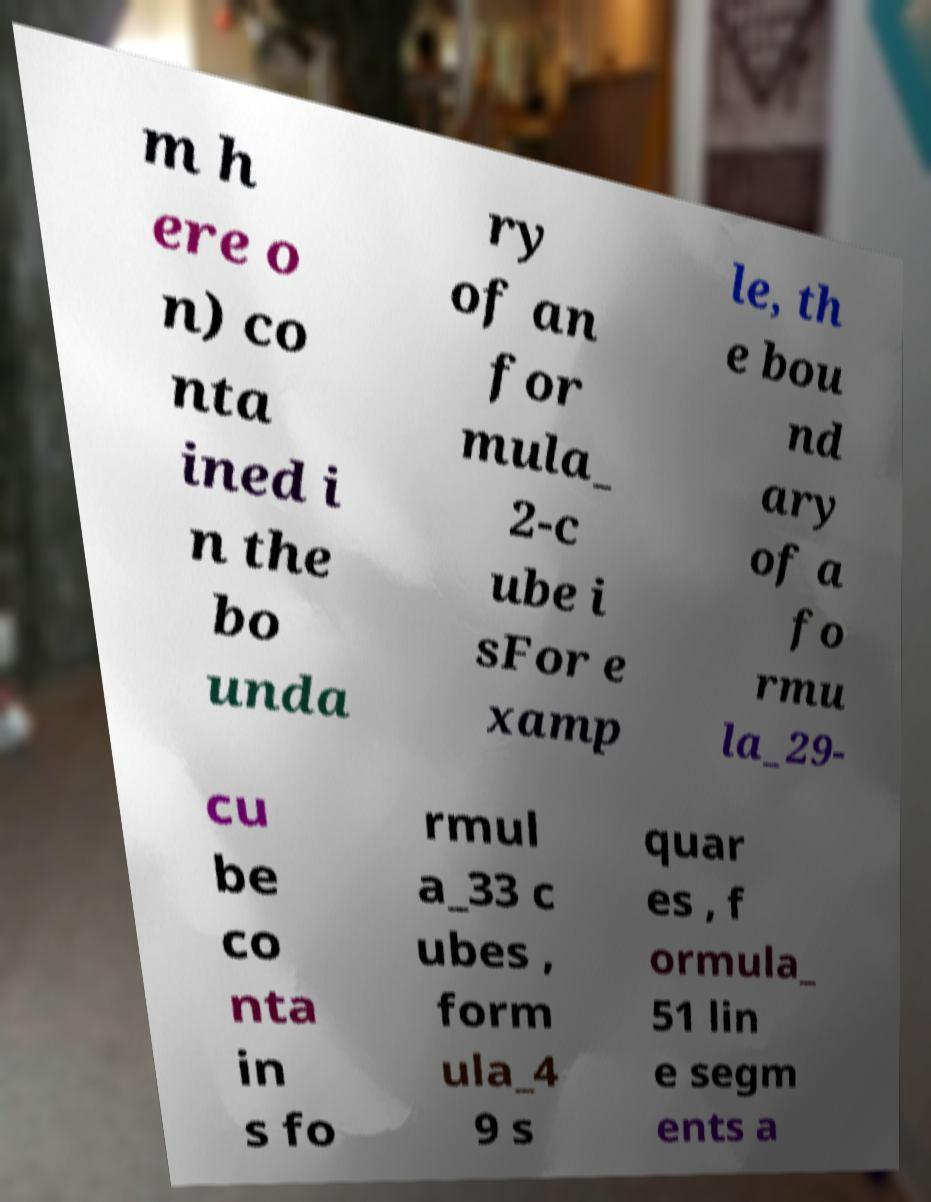I need the written content from this picture converted into text. Can you do that? m h ere o n) co nta ined i n the bo unda ry of an for mula_ 2-c ube i sFor e xamp le, th e bou nd ary of a fo rmu la_29- cu be co nta in s fo rmul a_33 c ubes , form ula_4 9 s quar es , f ormula_ 51 lin e segm ents a 